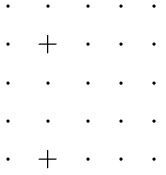Convert formula to latex. <formula><loc_0><loc_0><loc_500><loc_500>\begin{matrix} \, \cdot \, & \, \cdot \, & \, \cdot \, & \, \cdot \, & \, \cdot \, \\ \, \cdot \, & \, + \, & \, \cdot \, & \, \cdot \, & \, \cdot \, \\ \, \cdot \, & \, \cdot \, & \, \cdot \, & \, \cdot \, & \, \cdot \, \\ \, \cdot \, & \, \cdot \, & \, \cdot \, & \, \cdot \, & \, \cdot \, \\ \, \cdot \, & \, + \, & \, \cdot \, & \, \cdot \, & \, \cdot \, \\ \end{matrix}</formula> 